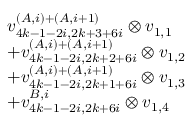<formula> <loc_0><loc_0><loc_500><loc_500>\begin{array} { r l } & { v _ { 4 k - 1 - 2 i , 2 k + 3 + 6 i } ^ { ( A , i ) + ( A , i + 1 ) } \otimes v _ { 1 , 1 } } \\ & { + v _ { 4 k - 1 - 2 i , 2 k + 2 + 6 i } ^ { ( A , i ) + ( A , i + 1 ) } \otimes v _ { 1 , 2 } } \\ & { + v _ { 4 k - 1 - 2 i , 2 k + 1 + 6 i } ^ { ( A , i ) + ( A , i + 1 ) } \otimes v _ { 1 , 3 } } \\ & { + v _ { 4 k - 1 - 2 i , 2 k + 6 i } ^ { B , i } \otimes v _ { 1 , 4 } } \end{array}</formula> 